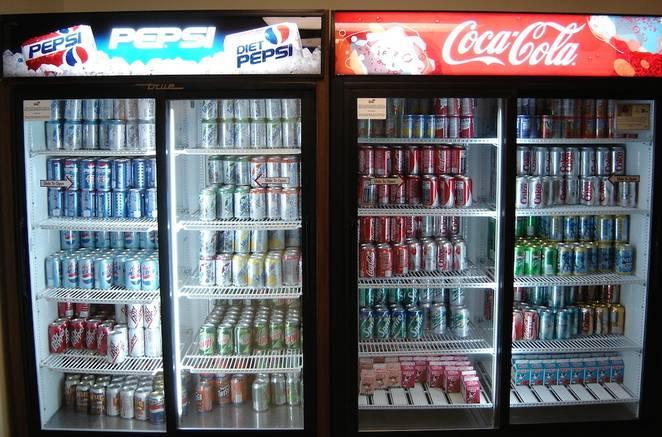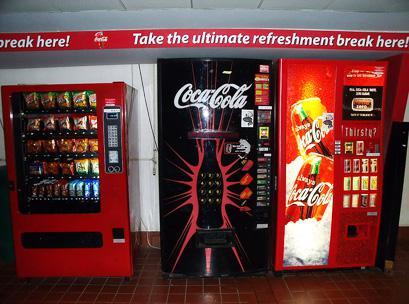The first image is the image on the left, the second image is the image on the right. Given the left and right images, does the statement "The machine on the right sells Coca Cola." hold true? Answer yes or no. Yes. 